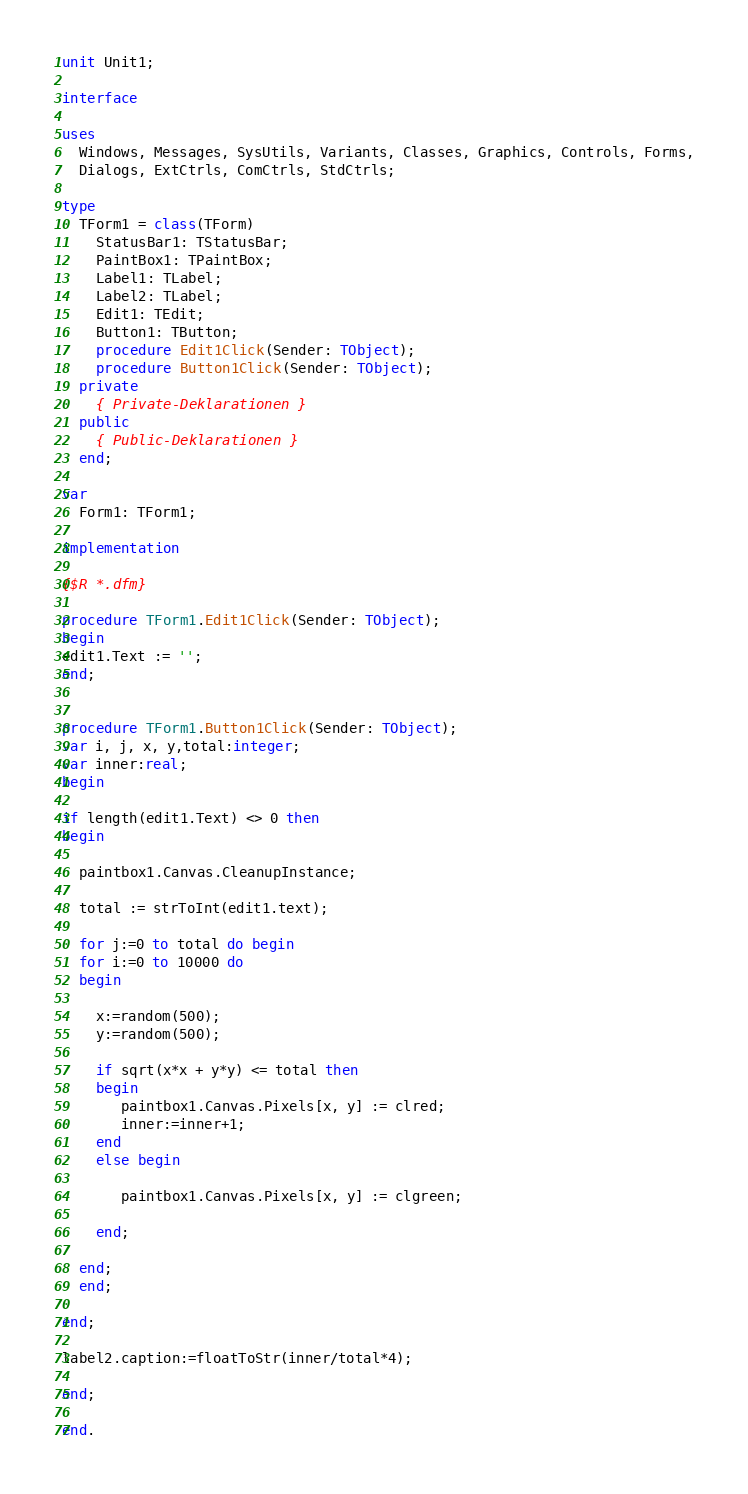<code> <loc_0><loc_0><loc_500><loc_500><_Pascal_>unit Unit1;

interface

uses
  Windows, Messages, SysUtils, Variants, Classes, Graphics, Controls, Forms,
  Dialogs, ExtCtrls, ComCtrls, StdCtrls;

type
  TForm1 = class(TForm)
    StatusBar1: TStatusBar;
    PaintBox1: TPaintBox;
    Label1: TLabel;
    Label2: TLabel;
    Edit1: TEdit;
    Button1: TButton;
    procedure Edit1Click(Sender: TObject);
    procedure Button1Click(Sender: TObject);
  private
    { Private-Deklarationen }
  public
    { Public-Deklarationen }
  end;

var
  Form1: TForm1;

implementation

{$R *.dfm}

procedure TForm1.Edit1Click(Sender: TObject);
begin
edit1.Text := '';
end;


procedure TForm1.Button1Click(Sender: TObject);
var i, j, x, y,total:integer;
var inner:real;
begin

if length(edit1.Text) <> 0 then
begin

  paintbox1.Canvas.CleanupInstance;

  total := strToInt(edit1.text);

  for j:=0 to total do begin
  for i:=0 to 10000 do
  begin

    x:=random(500);
    y:=random(500);

    if sqrt(x*x + y*y) <= total then
    begin
       paintbox1.Canvas.Pixels[x, y] := clred;
       inner:=inner+1;
    end
    else begin

       paintbox1.Canvas.Pixels[x, y] := clgreen;

    end;

  end;
  end;

end;

label2.caption:=floatToStr(inner/total*4);

end;

end.
</code> 